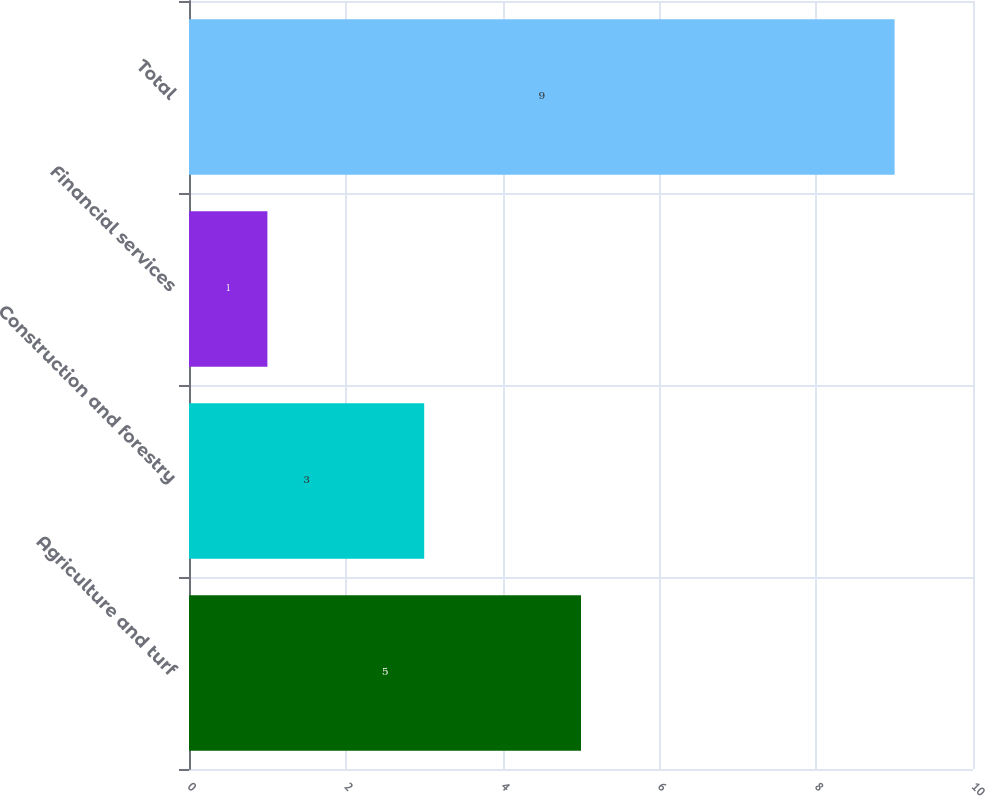Convert chart. <chart><loc_0><loc_0><loc_500><loc_500><bar_chart><fcel>Agriculture and turf<fcel>Construction and forestry<fcel>Financial services<fcel>Total<nl><fcel>5<fcel>3<fcel>1<fcel>9<nl></chart> 